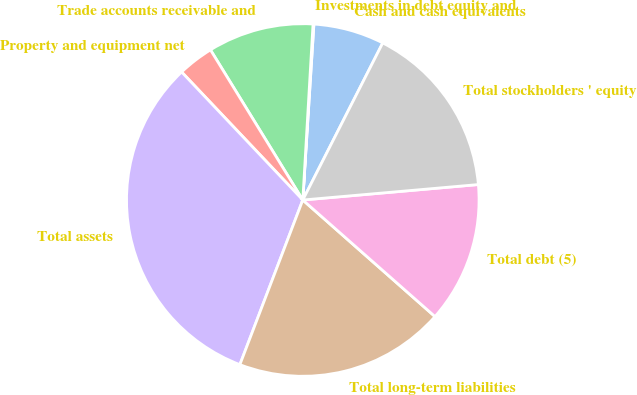<chart> <loc_0><loc_0><loc_500><loc_500><pie_chart><fcel>Cash and cash equivalents<fcel>Investments in debt equity and<fcel>Trade accounts receivable and<fcel>Property and equipment net<fcel>Total assets<fcel>Total long-term liabilities<fcel>Total debt (5)<fcel>Total stockholders ' equity<nl><fcel>6.49%<fcel>0.08%<fcel>9.7%<fcel>3.29%<fcel>32.13%<fcel>19.31%<fcel>12.9%<fcel>16.11%<nl></chart> 